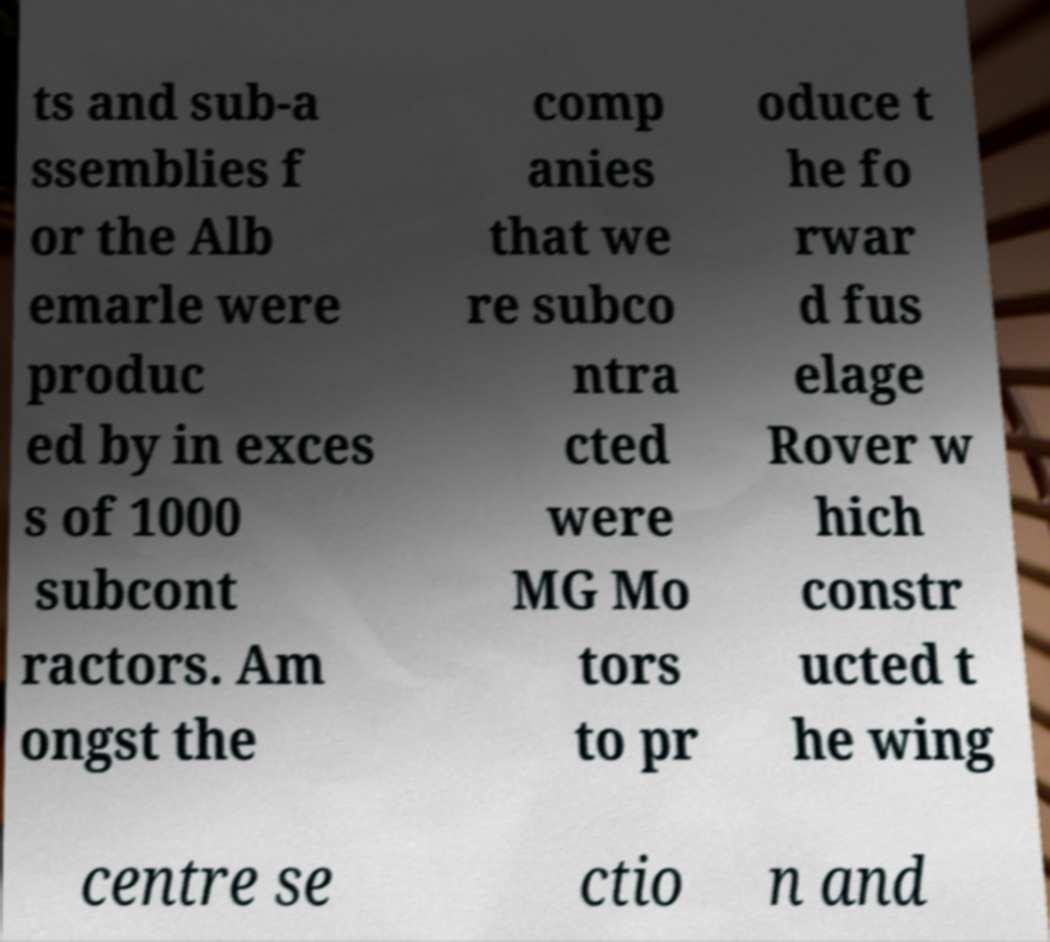Can you accurately transcribe the text from the provided image for me? ts and sub-a ssemblies f or the Alb emarle were produc ed by in exces s of 1000 subcont ractors. Am ongst the comp anies that we re subco ntra cted were MG Mo tors to pr oduce t he fo rwar d fus elage Rover w hich constr ucted t he wing centre se ctio n and 